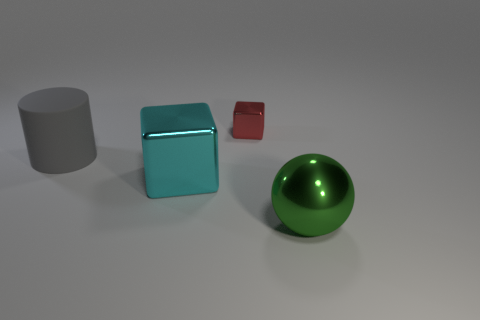There is a large thing right of the small red thing; what is its material?
Offer a terse response. Metal. Is there a gray metal object of the same shape as the red object?
Offer a terse response. No. What number of other objects have the same shape as the big cyan metal thing?
Your answer should be very brief. 1. There is a block that is behind the large cylinder; is it the same size as the metallic block in front of the gray thing?
Give a very brief answer. No. The big metallic object that is in front of the block to the left of the small red block is what shape?
Ensure brevity in your answer.  Sphere. Are there the same number of small red metallic objects that are on the left side of the large rubber object and large green metallic cylinders?
Ensure brevity in your answer.  Yes. What is the material of the large object that is on the left side of the block that is on the left side of the metal cube that is behind the large gray matte cylinder?
Your answer should be compact. Rubber. Are there any rubber cylinders that have the same size as the cyan shiny cube?
Make the answer very short. Yes. The tiny object has what shape?
Provide a short and direct response. Cube. How many balls are large cyan metal things or large gray matte objects?
Offer a very short reply. 0. 